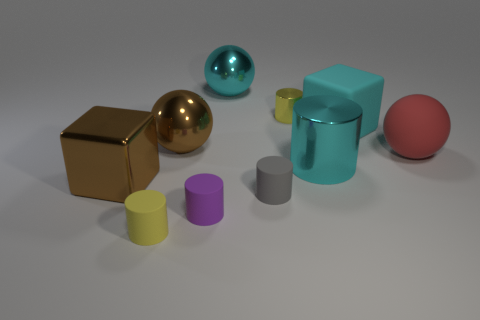Subtract all cyan cylinders. How many cylinders are left? 4 Subtract all small yellow rubber cylinders. How many cylinders are left? 4 Subtract all blue cylinders. Subtract all brown spheres. How many cylinders are left? 5 Subtract all cubes. How many objects are left? 8 Add 9 small gray shiny things. How many small gray shiny things exist? 9 Subtract 1 gray cylinders. How many objects are left? 9 Subtract all small brown things. Subtract all large things. How many objects are left? 4 Add 6 metallic spheres. How many metallic spheres are left? 8 